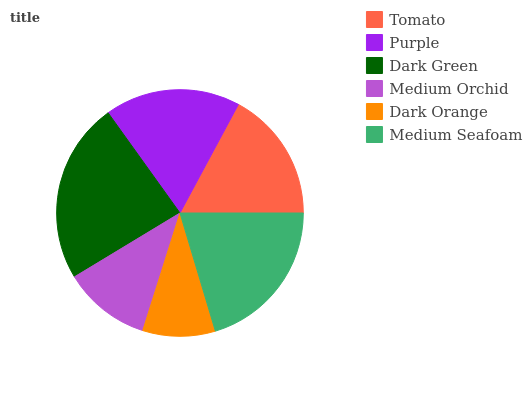Is Dark Orange the minimum?
Answer yes or no. Yes. Is Dark Green the maximum?
Answer yes or no. Yes. Is Purple the minimum?
Answer yes or no. No. Is Purple the maximum?
Answer yes or no. No. Is Purple greater than Tomato?
Answer yes or no. Yes. Is Tomato less than Purple?
Answer yes or no. Yes. Is Tomato greater than Purple?
Answer yes or no. No. Is Purple less than Tomato?
Answer yes or no. No. Is Purple the high median?
Answer yes or no. Yes. Is Tomato the low median?
Answer yes or no. Yes. Is Tomato the high median?
Answer yes or no. No. Is Purple the low median?
Answer yes or no. No. 